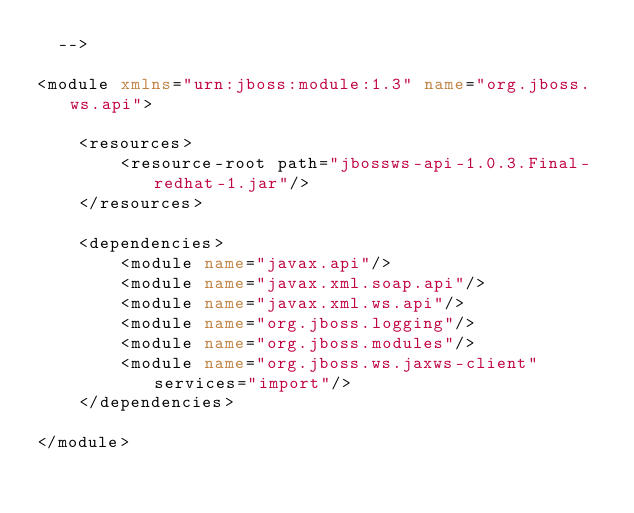<code> <loc_0><loc_0><loc_500><loc_500><_XML_>  -->

<module xmlns="urn:jboss:module:1.3" name="org.jboss.ws.api">

    <resources>
        <resource-root path="jbossws-api-1.0.3.Final-redhat-1.jar"/>
    </resources>

    <dependencies>
        <module name="javax.api"/>
        <module name="javax.xml.soap.api"/>
        <module name="javax.xml.ws.api"/>
        <module name="org.jboss.logging"/>
        <module name="org.jboss.modules"/>
        <module name="org.jboss.ws.jaxws-client" services="import"/>
    </dependencies>

</module>
</code> 